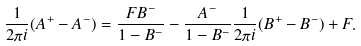<formula> <loc_0><loc_0><loc_500><loc_500>\frac { 1 } { 2 \pi i } ( A ^ { + } - A ^ { - } ) = \frac { F B ^ { - } } { 1 - B ^ { - } } - \frac { A ^ { - } } { 1 - B ^ { - } } \frac { 1 } { 2 \pi i } ( B ^ { + } - B ^ { - } ) + F .</formula> 